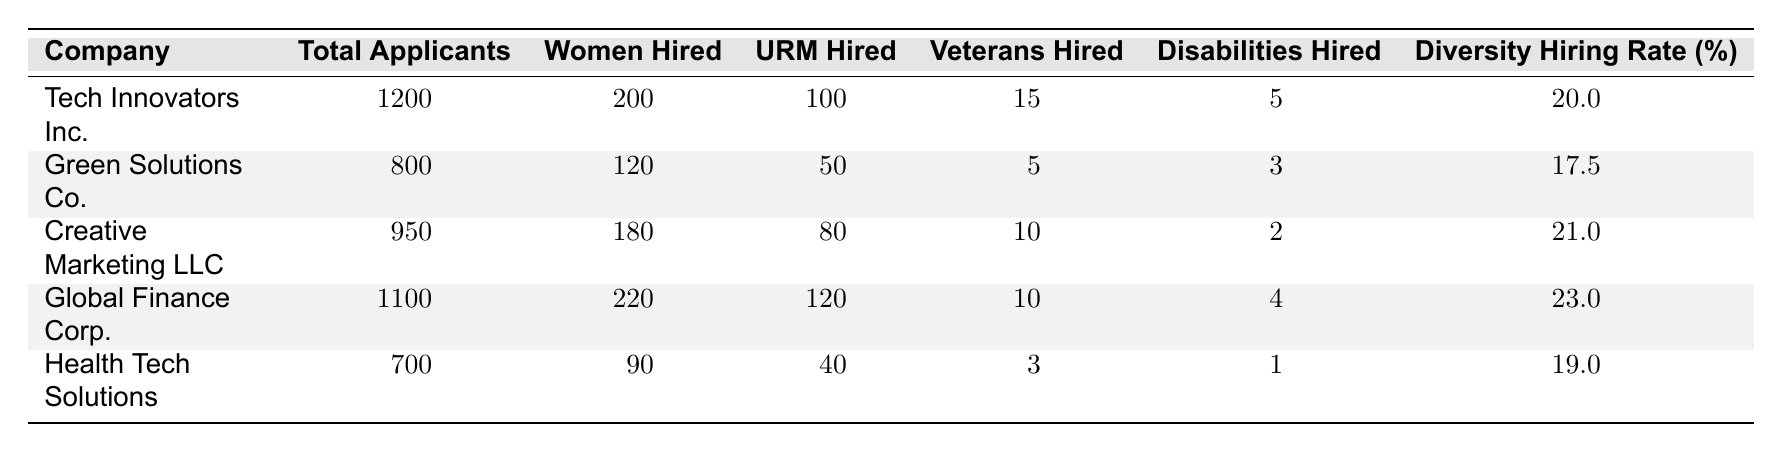What is the highest number of women hired among the companies? From the table, Global Finance Corp. hired the highest number of women with 220 hired, which can be seen by comparing the values in the "Women Hired" column.
Answer: 220 Which company has the highest diversity hiring rate? By examining the "Diversity Hiring Rate (%)" column, Global Finance Corp. has the highest diversity hiring rate at 23.0%, as it is the largest value in that column.
Answer: 23.0 How many total applicants were there for Creative Marketing LLC? The total applicants for Creative Marketing LLC are directly listed in the "Total Applicants" column, which states there were 950 applicants.
Answer: 950 What is the difference in the number of underrepresented minorities hired between Tech Innovators Inc. and Green Solutions Co.? Tech Innovators Inc. hired 100 underrepresented minorities, while Green Solutions Co. hired 50. The difference is calculated as 100 - 50 = 50.
Answer: 50 What percentage of overall hiring does Health Tech Solutions represent based on its applicants? Health Tech Solutions hired 90 out of 700 total applicants. The overall hiring rate is calculated as (90/700)*100 = 12.9%, which is lower than other companies. However, it is stated in the table that their overall hiring rate is 18.0%, focusing on the provided information.
Answer: 18.0 Is Green Solutions Co. the only company with a diversity hiring rate below 20%? To determine this, we can check the diversity hiring rates of all companies. Green Solutions Co. has a 17.5% rate, while Tech Innovators Inc. has 20.0% and Health Tech Solutions has 19.0%. Therefore, Green Solutions Co. is not the only company below 20% as both Green Solutions Co. and Health Tech Solutions fall below this threshold.
Answer: No What is the total number of veterans hired across all companies? To find the total number of veterans hired, we sum the veterans hired from all companies: 15 + 5 + 10 + 10 + 3 = 43.
Answer: 43 How would you compare the diversity hiring rates for Creative Marketing LLC and Health Tech Solutions? Creative Marketing LLC has a diversity hiring rate of 21.0%, while Health Tech Solutions has a rate of 19.0%. By examining the figures directly in the table, it's clear that Creative Marketing LLC has a higher diversity hiring rate compared to Health Tech Solutions.
Answer: Creative Marketing LLC is higher 